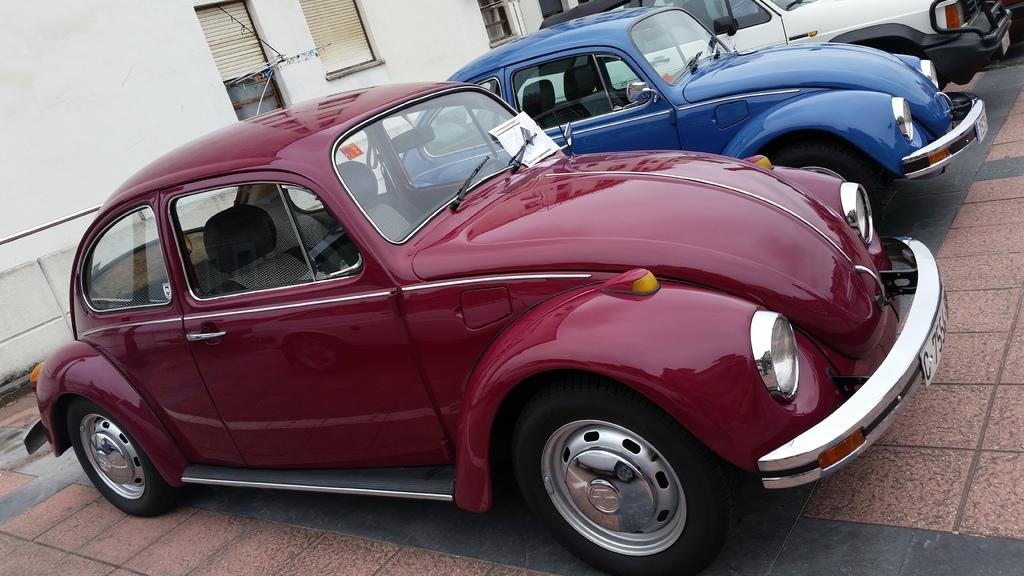What type of vehicles are in the front of the image? There are cars in the front of the image. What structure can be seen in the background of the image? There is a building in the background of the image. What feature is common to both the cars and the building? Windows are visible in the image, both on the cars and in the building. Can you hear a whistle in the image? There is no indication of a whistle in the image, as it is a visual representation and does not include sound. 